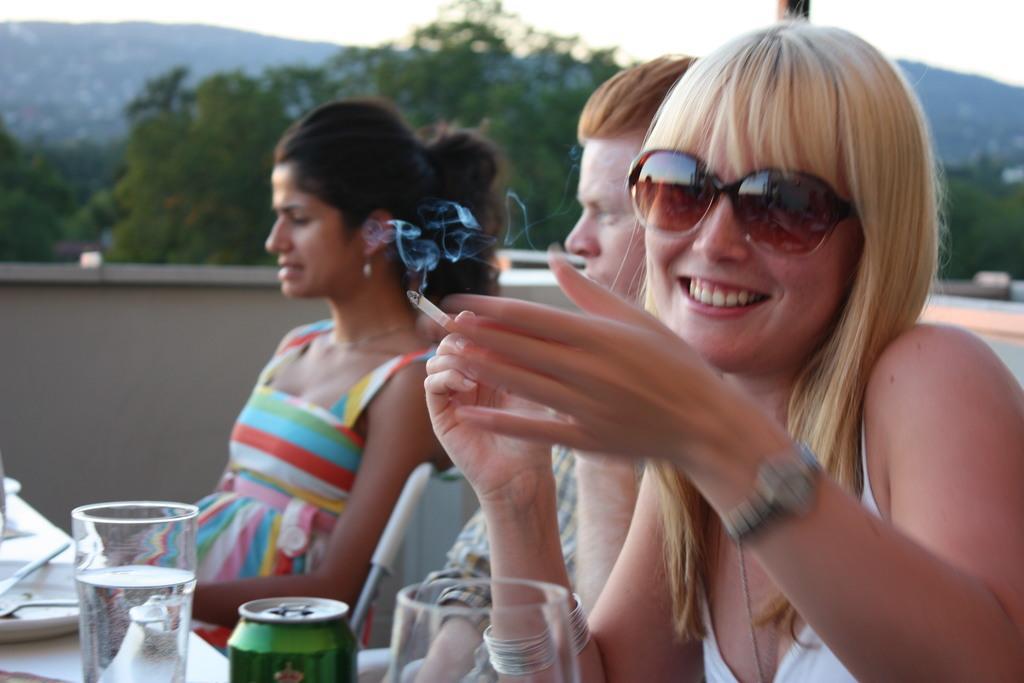How would you summarize this image in a sentence or two? In the foreground of the picture there is a woman holding a cigarette. On the left there is a table, on the table there are glasses, tin, plate and spoons. In the center of the picture there is a man and a woman. The background is blurred. In the background there are trees and hills. 